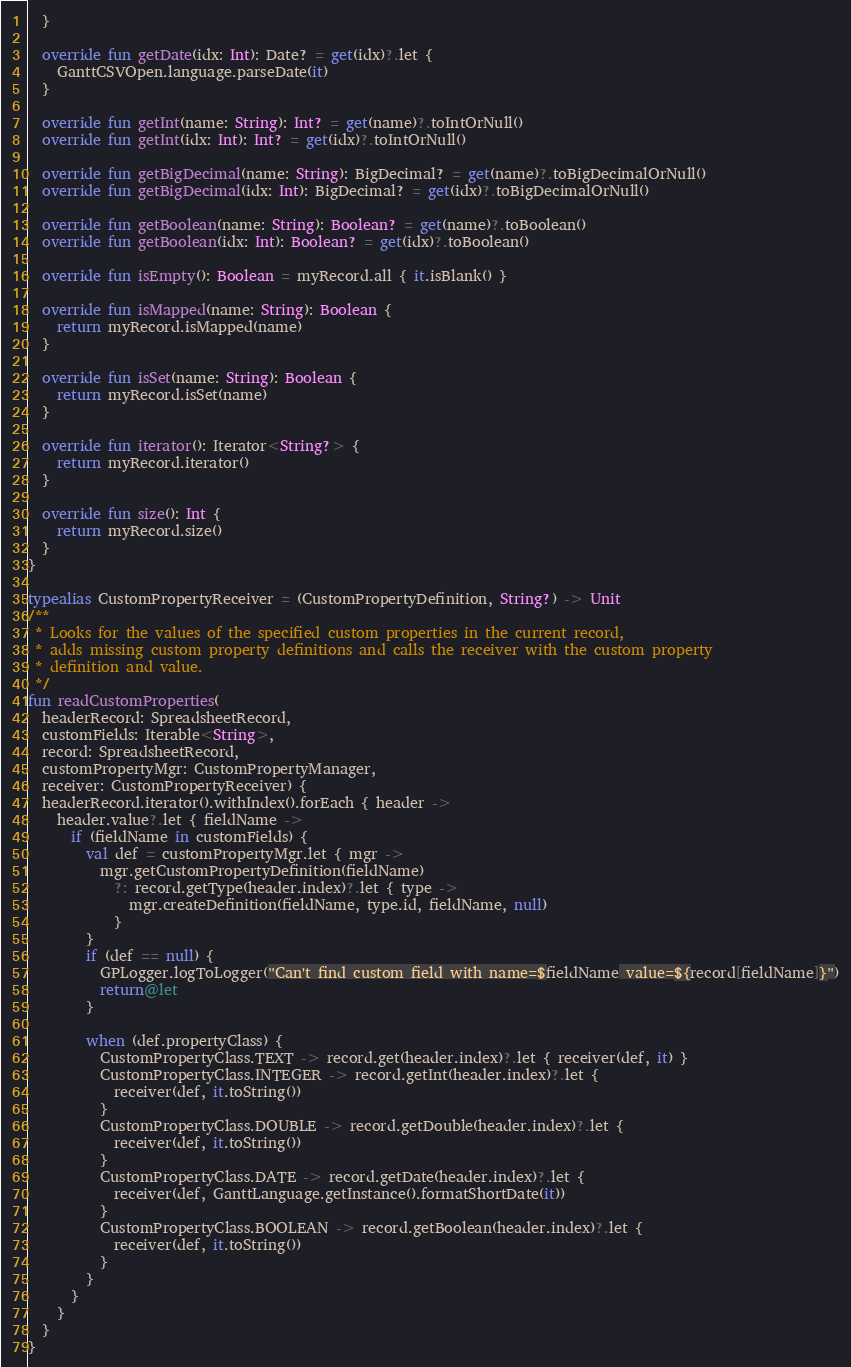<code> <loc_0><loc_0><loc_500><loc_500><_Kotlin_>  }

  override fun getDate(idx: Int): Date? = get(idx)?.let {
    GanttCSVOpen.language.parseDate(it)
  }

  override fun getInt(name: String): Int? = get(name)?.toIntOrNull()
  override fun getInt(idx: Int): Int? = get(idx)?.toIntOrNull()

  override fun getBigDecimal(name: String): BigDecimal? = get(name)?.toBigDecimalOrNull()
  override fun getBigDecimal(idx: Int): BigDecimal? = get(idx)?.toBigDecimalOrNull()

  override fun getBoolean(name: String): Boolean? = get(name)?.toBoolean()
  override fun getBoolean(idx: Int): Boolean? = get(idx)?.toBoolean()

  override fun isEmpty(): Boolean = myRecord.all { it.isBlank() }

  override fun isMapped(name: String): Boolean {
    return myRecord.isMapped(name)
  }

  override fun isSet(name: String): Boolean {
    return myRecord.isSet(name)
  }

  override fun iterator(): Iterator<String?> {
    return myRecord.iterator()
  }

  override fun size(): Int {
    return myRecord.size()
  }
}

typealias CustomPropertyReceiver = (CustomPropertyDefinition, String?) -> Unit
/**
 * Looks for the values of the specified custom properties in the current record,
 * adds missing custom property definitions and calls the receiver with the custom property
 * definition and value.
 */
fun readCustomProperties(
  headerRecord: SpreadsheetRecord,
  customFields: Iterable<String>,
  record: SpreadsheetRecord,
  customPropertyMgr: CustomPropertyManager,
  receiver: CustomPropertyReceiver) {
  headerRecord.iterator().withIndex().forEach { header ->
    header.value?.let { fieldName ->
      if (fieldName in customFields) {
        val def = customPropertyMgr.let { mgr ->
          mgr.getCustomPropertyDefinition(fieldName)
            ?: record.getType(header.index)?.let { type ->
              mgr.createDefinition(fieldName, type.id, fieldName, null)
            }
        }
        if (def == null) {
          GPLogger.logToLogger("Can't find custom field with name=$fieldName value=${record[fieldName]}")
          return@let
        }

        when (def.propertyClass) {
          CustomPropertyClass.TEXT -> record.get(header.index)?.let { receiver(def, it) }
          CustomPropertyClass.INTEGER -> record.getInt(header.index)?.let {
            receiver(def, it.toString())
          }
          CustomPropertyClass.DOUBLE -> record.getDouble(header.index)?.let {
            receiver(def, it.toString())
          }
          CustomPropertyClass.DATE -> record.getDate(header.index)?.let {
            receiver(def, GanttLanguage.getInstance().formatShortDate(it))
          }
          CustomPropertyClass.BOOLEAN -> record.getBoolean(header.index)?.let {
            receiver(def, it.toString())
          }
        }
      }
    }
  }
}
</code> 